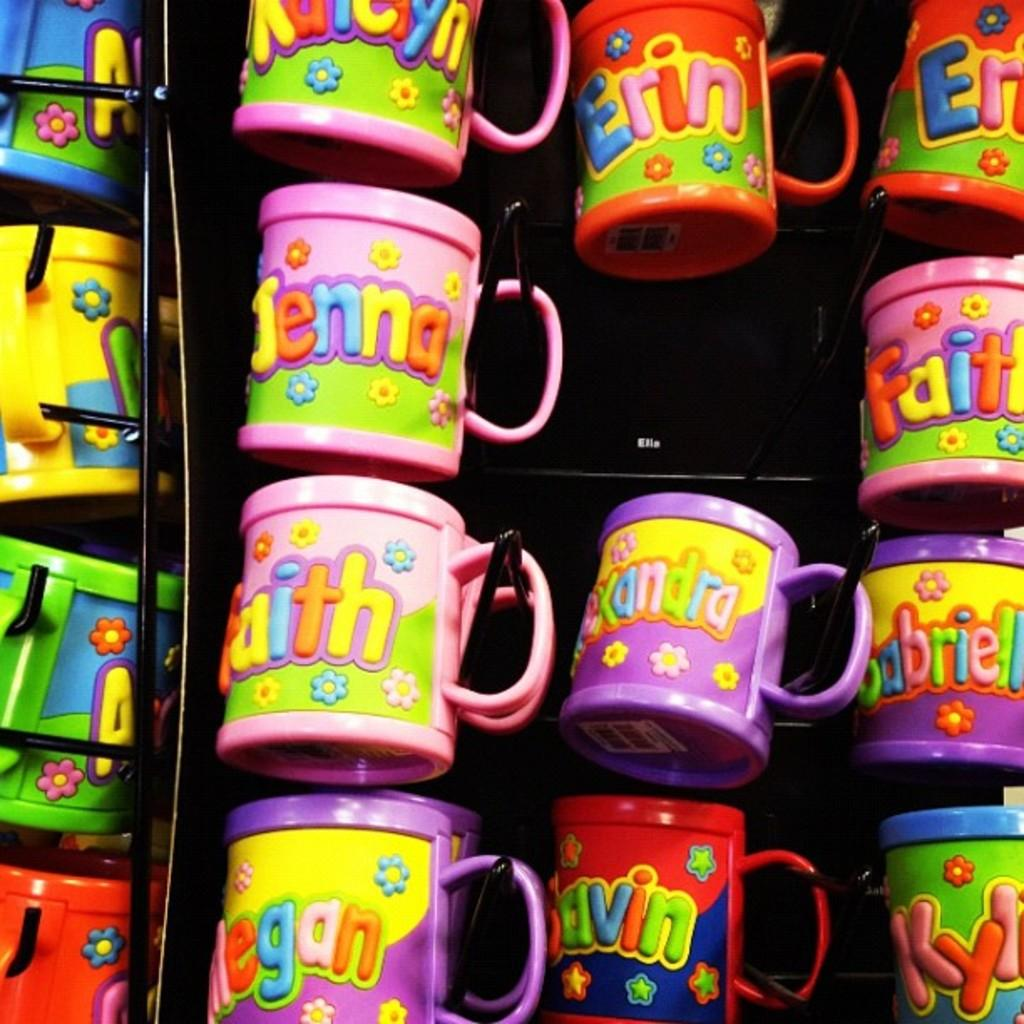What objects are present in the image? There are cups in the image. How many colors are the cups? The cups have different colors. What specific colors can be seen on the cups? The colors mentioned are pink, pink, purple, red, blue, and yellow. What is the chance of the cups expanding in the image? There is no indication in the image that the cups are expanding or have the ability to expand. 